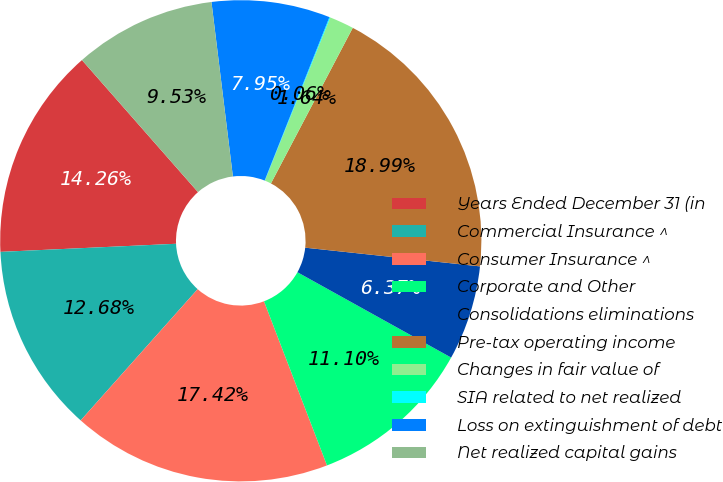Convert chart to OTSL. <chart><loc_0><loc_0><loc_500><loc_500><pie_chart><fcel>Years Ended December 31 (in<fcel>Commercial Insurance ^<fcel>Consumer Insurance ^<fcel>Corporate and Other<fcel>Consolidations eliminations<fcel>Pre-tax operating income<fcel>Changes in fair value of<fcel>SIA related to net realized<fcel>Loss on extinguishment of debt<fcel>Net realized capital gains<nl><fcel>14.26%<fcel>12.68%<fcel>17.42%<fcel>11.1%<fcel>6.37%<fcel>18.99%<fcel>1.64%<fcel>0.06%<fcel>7.95%<fcel>9.53%<nl></chart> 